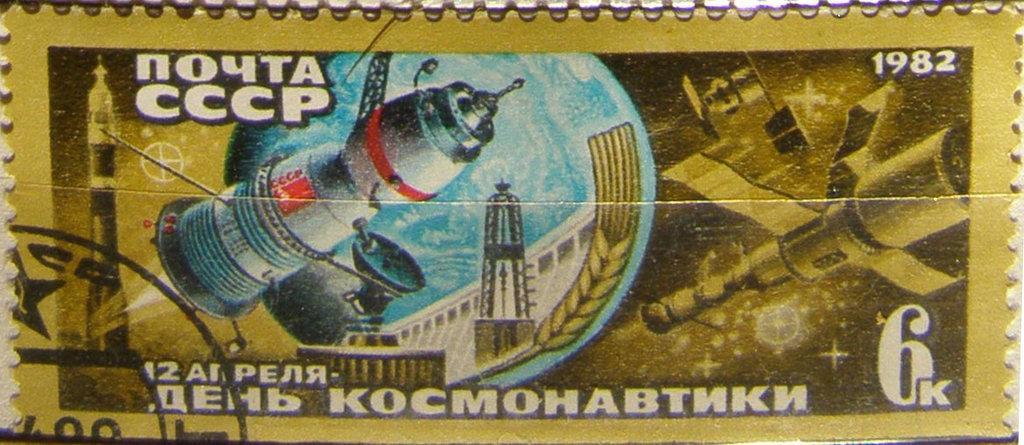What is the main subject of the image? The main subject of the image is a stamp. What is depicted on the stamp? The stamp features rockets, a dish antenna, a tower, a building, satellites, numbers, and some text. Can you describe the theme of the stamp? The stamp has a space-related theme, featuring various elements related to space exploration and technology. What type of sponge is being used to clean the vest in the image? There is no sponge or vest present in the image; it features a stamp with a space-related theme. How many pickles are visible on the building depicted on the stamp? There are no pickles depicted on the building or any other part of the stamp in the image. 